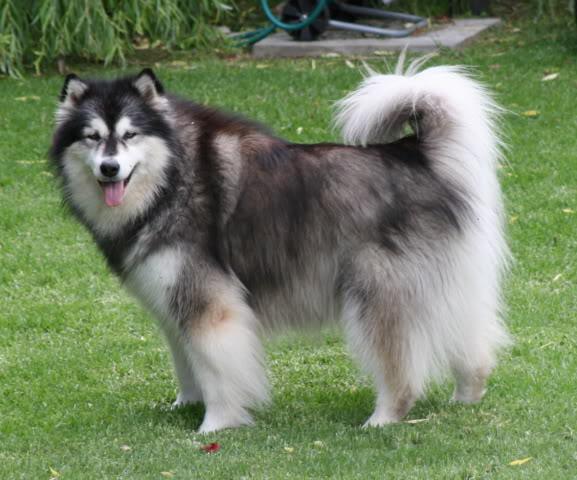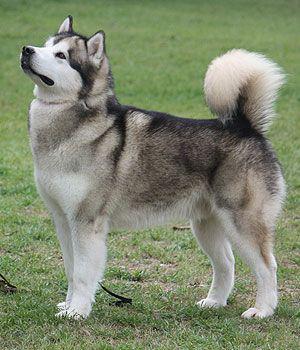The first image is the image on the left, the second image is the image on the right. Assess this claim about the two images: "Both dogs have their mouths open.". Correct or not? Answer yes or no. No. The first image is the image on the left, the second image is the image on the right. Analyze the images presented: Is the assertion "There are two dogs with their mouths open." valid? Answer yes or no. No. 